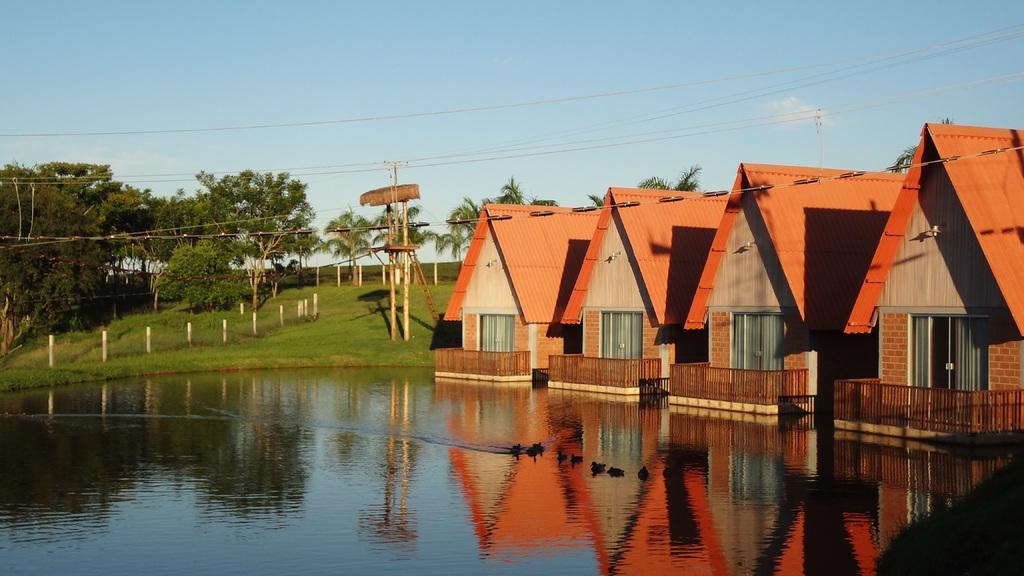Describe this image in one or two sentences. Here we can see water, houses, poles, wires, and trees. In the background there is sky. 